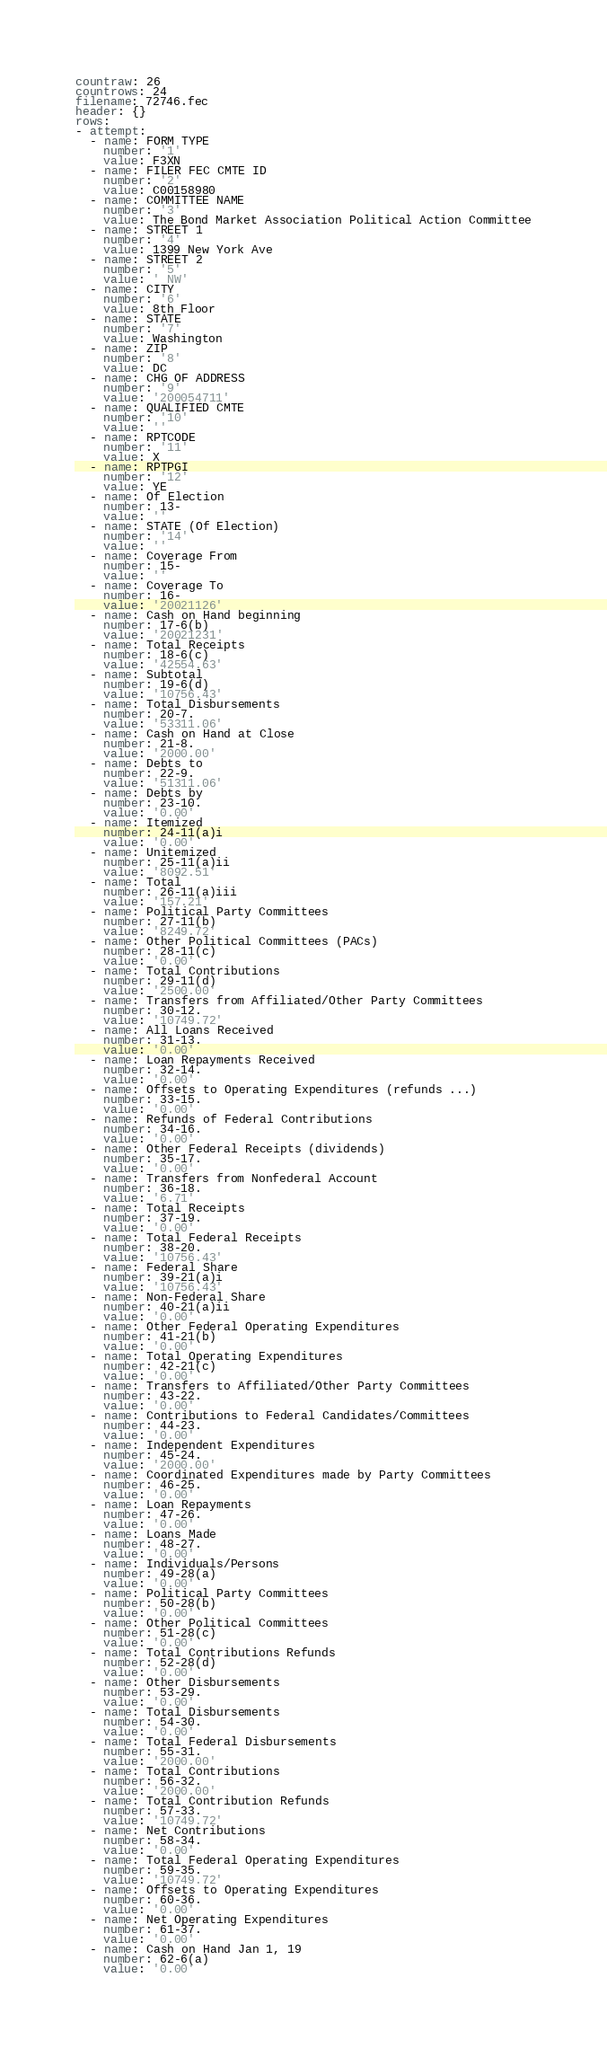Convert code to text. <code><loc_0><loc_0><loc_500><loc_500><_YAML_>countraw: 26
countrows: 24
filename: 72746.fec
header: {}
rows:
- attempt:
  - name: FORM TYPE
    number: '1'
    value: F3XN
  - name: FILER FEC CMTE ID
    number: '2'
    value: C00158980
  - name: COMMITTEE NAME
    number: '3'
    value: The Bond Market Association Political Action Committee
  - name: STREET 1
    number: '4'
    value: 1399 New York Ave
  - name: STREET 2
    number: '5'
    value: ' NW'
  - name: CITY
    number: '6'
    value: 8th Floor
  - name: STATE
    number: '7'
    value: Washington
  - name: ZIP
    number: '8'
    value: DC
  - name: CHG OF ADDRESS
    number: '9'
    value: '200054711'
  - name: QUALIFIED CMTE
    number: '10'
    value: ''
  - name: RPTCODE
    number: '11'
    value: X
  - name: RPTPGI
    number: '12'
    value: YE
  - name: Of Election
    number: 13-
    value: ''
  - name: STATE (Of Election)
    number: '14'
    value: ''
  - name: Coverage From
    number: 15-
    value: ''
  - name: Coverage To
    number: 16-
    value: '20021126'
  - name: Cash on Hand beginning
    number: 17-6(b)
    value: '20021231'
  - name: Total Receipts
    number: 18-6(c)
    value: '42554.63'
  - name: Subtotal
    number: 19-6(d)
    value: '10756.43'
  - name: Total Disbursements
    number: 20-7.
    value: '53311.06'
  - name: Cash on Hand at Close
    number: 21-8.
    value: '2000.00'
  - name: Debts to
    number: 22-9.
    value: '51311.06'
  - name: Debts by
    number: 23-10.
    value: '0.00'
  - name: Itemized
    number: 24-11(a)i
    value: '0.00'
  - name: Unitemized
    number: 25-11(a)ii
    value: '8092.51'
  - name: Total
    number: 26-11(a)iii
    value: '157.21'
  - name: Political Party Committees
    number: 27-11(b)
    value: '8249.72'
  - name: Other Political Committees (PACs)
    number: 28-11(c)
    value: '0.00'
  - name: Total Contributions
    number: 29-11(d)
    value: '2500.00'
  - name: Transfers from Affiliated/Other Party Committees
    number: 30-12.
    value: '10749.72'
  - name: All Loans Received
    number: 31-13.
    value: '0.00'
  - name: Loan Repayments Received
    number: 32-14.
    value: '0.00'
  - name: Offsets to Operating Expenditures (refunds ...)
    number: 33-15.
    value: '0.00'
  - name: Refunds of Federal Contributions
    number: 34-16.
    value: '0.00'
  - name: Other Federal Receipts (dividends)
    number: 35-17.
    value: '0.00'
  - name: Transfers from Nonfederal Account
    number: 36-18.
    value: '6.71'
  - name: Total Receipts
    number: 37-19.
    value: '0.00'
  - name: Total Federal Receipts
    number: 38-20.
    value: '10756.43'
  - name: Federal Share
    number: 39-21(a)i
    value: '10756.43'
  - name: Non-Federal Share
    number: 40-21(a)ii
    value: '0.00'
  - name: Other Federal Operating Expenditures
    number: 41-21(b)
    value: '0.00'
  - name: Total Operating Expenditures
    number: 42-21(c)
    value: '0.00'
  - name: Transfers to Affiliated/Other Party Committees
    number: 43-22.
    value: '0.00'
  - name: Contributions to Federal Candidates/Committees
    number: 44-23.
    value: '0.00'
  - name: Independent Expenditures
    number: 45-24.
    value: '2000.00'
  - name: Coordinated Expenditures made by Party Committees
    number: 46-25.
    value: '0.00'
  - name: Loan Repayments
    number: 47-26.
    value: '0.00'
  - name: Loans Made
    number: 48-27.
    value: '0.00'
  - name: Individuals/Persons
    number: 49-28(a)
    value: '0.00'
  - name: Political Party Committees
    number: 50-28(b)
    value: '0.00'
  - name: Other Political Committees
    number: 51-28(c)
    value: '0.00'
  - name: Total Contributions Refunds
    number: 52-28(d)
    value: '0.00'
  - name: Other Disbursements
    number: 53-29.
    value: '0.00'
  - name: Total Disbursements
    number: 54-30.
    value: '0.00'
  - name: Total Federal Disbursements
    number: 55-31.
    value: '2000.00'
  - name: Total Contributions
    number: 56-32.
    value: '2000.00'
  - name: Total Contribution Refunds
    number: 57-33.
    value: '10749.72'
  - name: Net Contributions
    number: 58-34.
    value: '0.00'
  - name: Total Federal Operating Expenditures
    number: 59-35.
    value: '10749.72'
  - name: Offsets to Operating Expenditures
    number: 60-36.
    value: '0.00'
  - name: Net Operating Expenditures
    number: 61-37.
    value: '0.00'
  - name: Cash on Hand Jan 1, 19
    number: 62-6(a)
    value: '0.00'</code> 